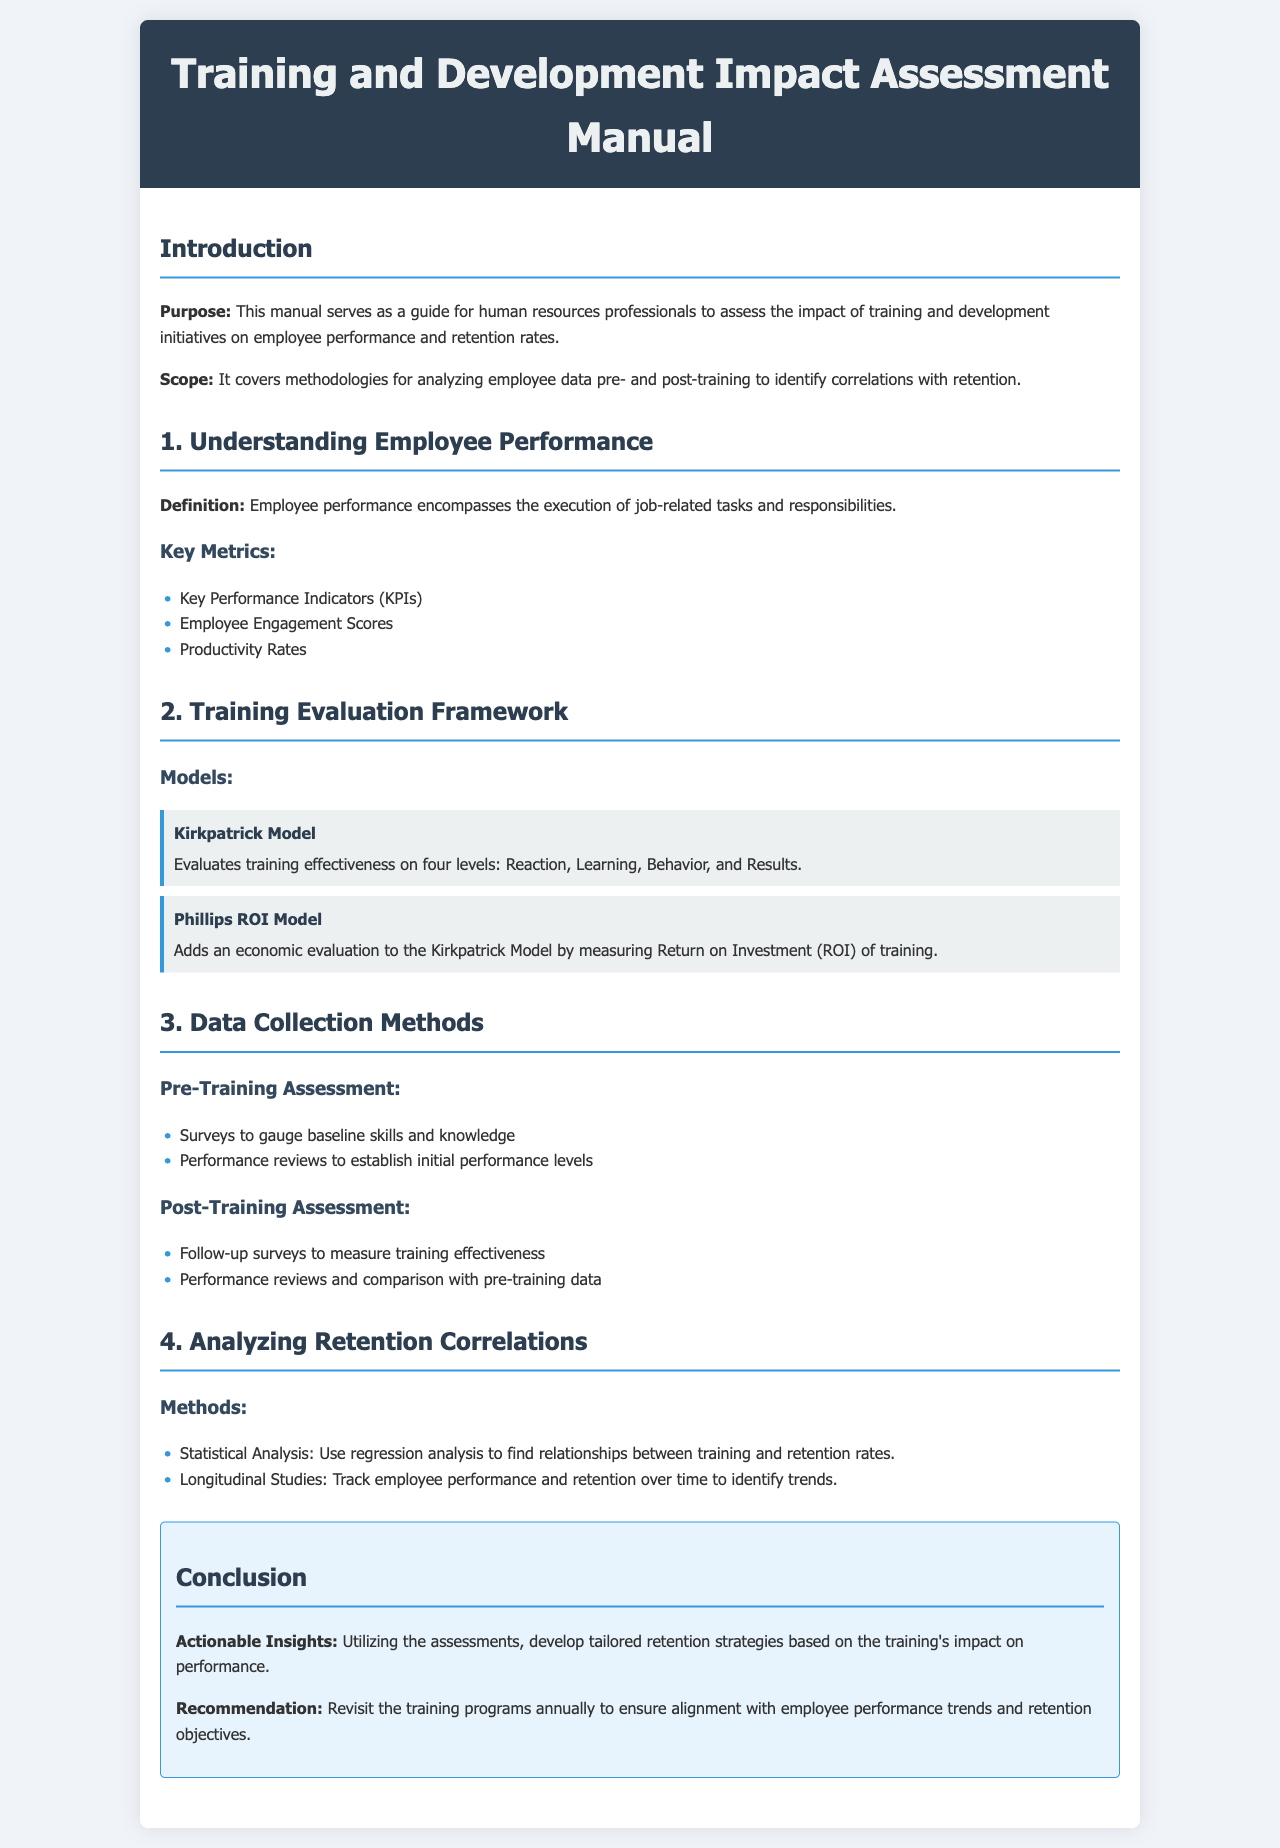What is the purpose of the manual? The purpose is to guide human resources professionals in assessing the impact of training and development initiatives on employee performance and retention rates.
Answer: Guide human resources professionals What is the first key metric listed under employee performance? The key metrics are listed in a bullet format, where the first one is Key Performance Indicators (KPIs).
Answer: Key Performance Indicators (KPIs) What model evaluates training effectiveness on four levels? The manual describes the Kirkpatrick Model, which evaluates training effectiveness on four levels: Reaction, Learning, Behavior, and Results.
Answer: Kirkpatrick Model What type of analysis is suggested to find relationships between training and retention rates? The document recommends using regression analysis as part of the statistical analysis method.
Answer: Regression analysis What is one method for pre-training assessment? The document lists surveys to gauge baseline skills and knowledge as one of the methods for pre-training assessment.
Answer: Surveys How often should training programs be revisited according to the recommendations? The manual suggests revisiting the training programs annually to ensure alignment with employee performance trends and retention objectives.
Answer: Annually What added a financial aspect to the Kirkpatrick Model? The Phillips ROI Model adds an economic evaluation to the Kirkpatrick Model by measuring Return on Investment (ROI) of training.
Answer: Phillips ROI Model What is a potential outcome of utilizing the assessments from this manual? The actionable insights suggest developing tailored retention strategies based on the training's impact on performance as a potential outcome.
Answer: Tailored retention strategies What is the main focus of Section 4 of the manual? Section 4 focuses on analyzing retention correlations and includes methods for this analysis.
Answer: Analyzing retention correlations 